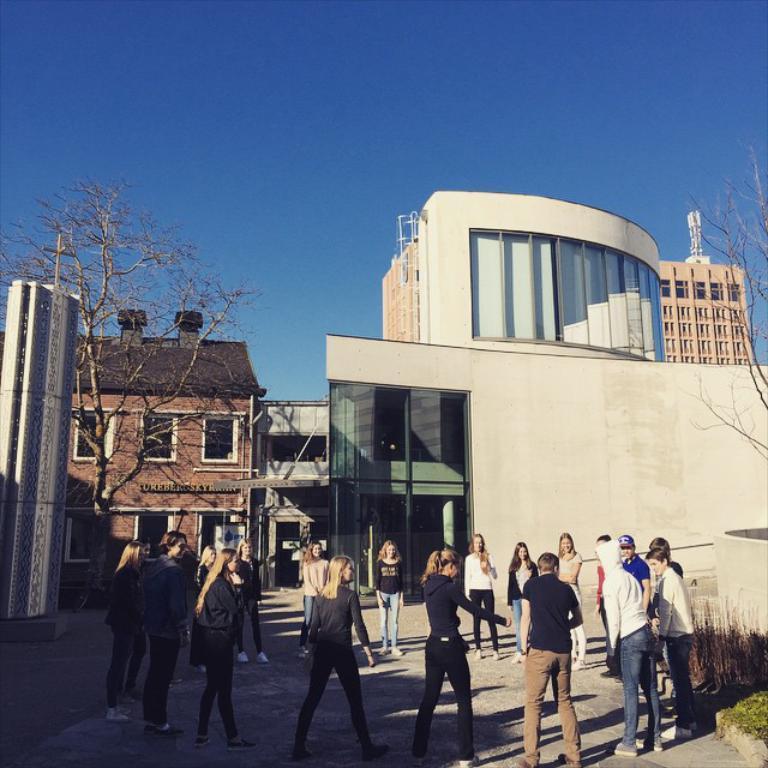How would you summarize this image in a sentence or two? In this image there are a few people standing on the surface, forming a circle, behind them there are building and trees. 